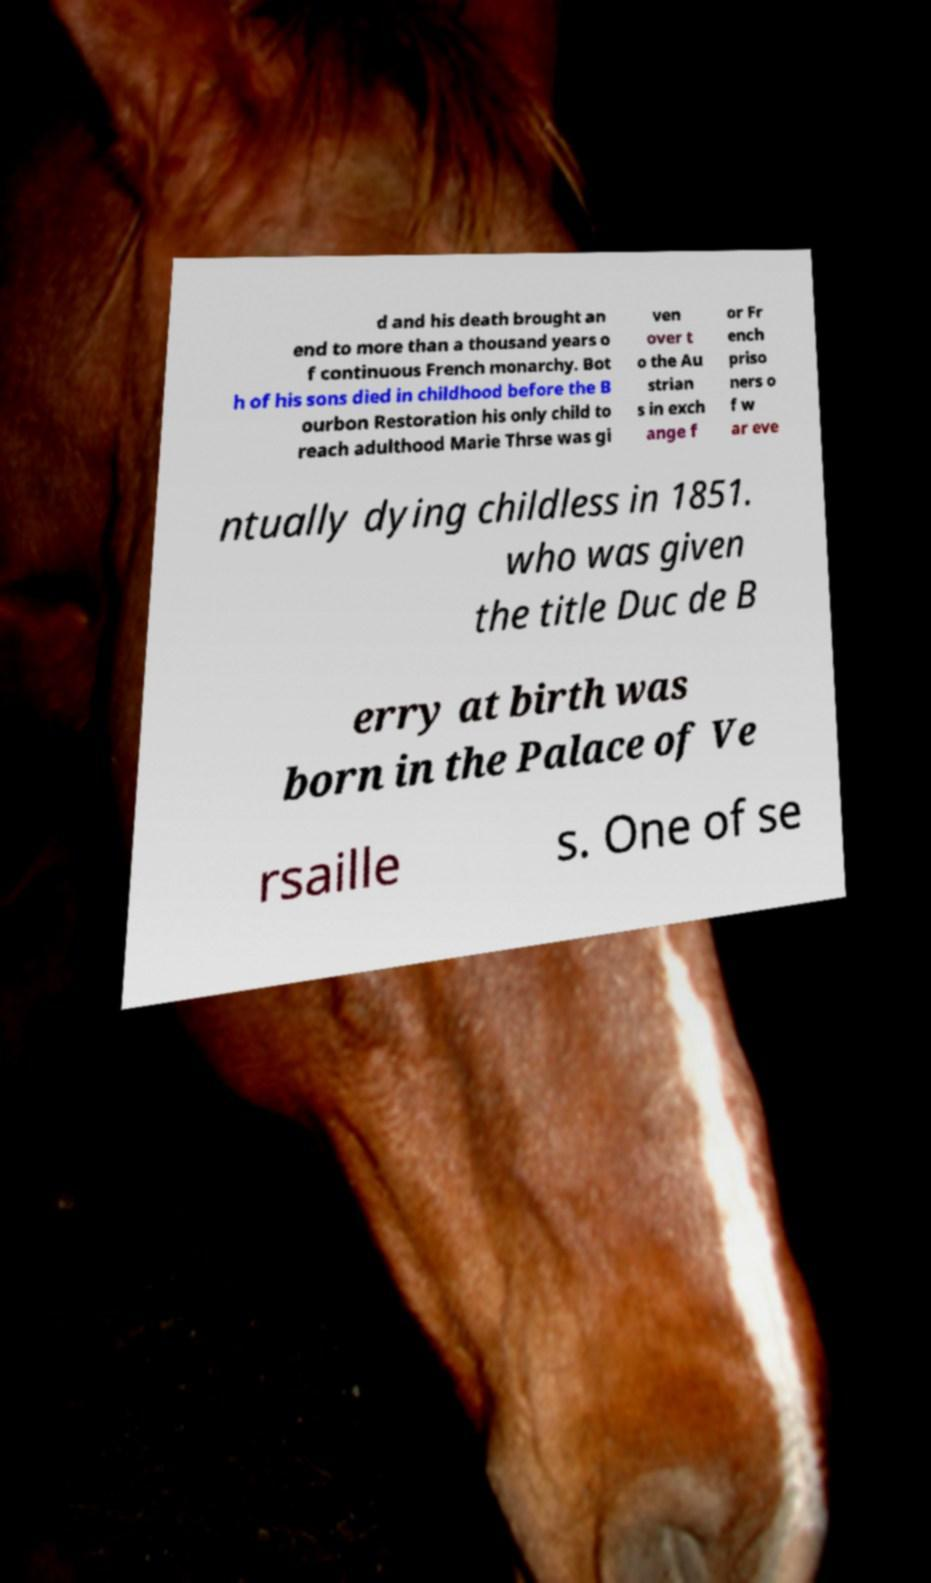For documentation purposes, I need the text within this image transcribed. Could you provide that? d and his death brought an end to more than a thousand years o f continuous French monarchy. Bot h of his sons died in childhood before the B ourbon Restoration his only child to reach adulthood Marie Thrse was gi ven over t o the Au strian s in exch ange f or Fr ench priso ners o f w ar eve ntually dying childless in 1851. who was given the title Duc de B erry at birth was born in the Palace of Ve rsaille s. One of se 